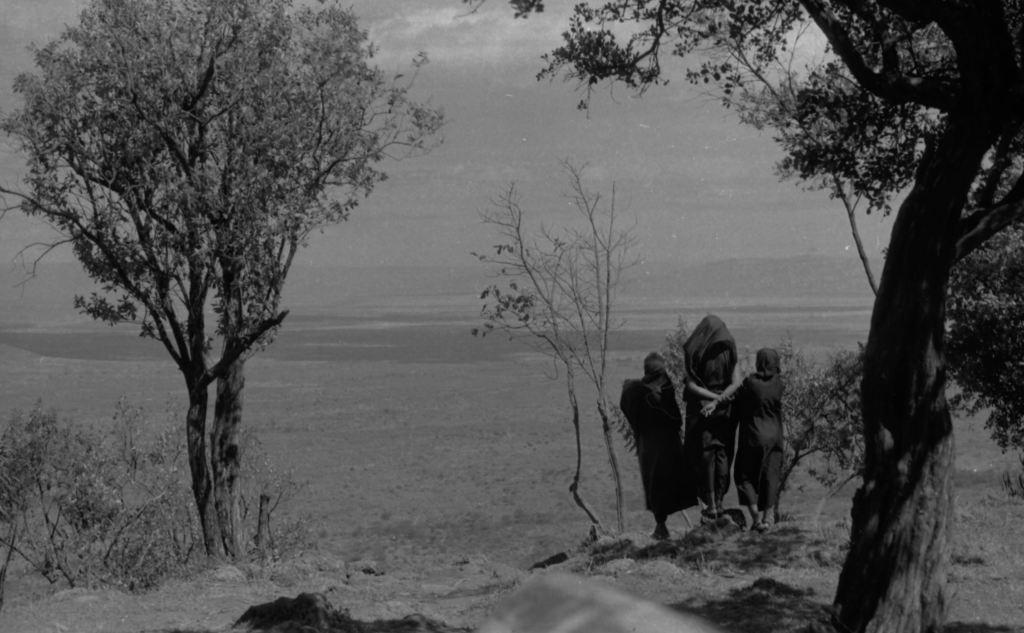Can you describe this image briefly? In this image I can see 3 persons in front and I see few trees. In the background I can see an open ground and the sky. 